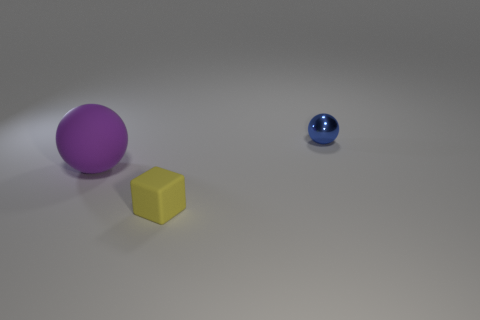Subtract all brown spheres. Subtract all yellow blocks. How many spheres are left? 2 Add 2 big matte spheres. How many objects exist? 5 Subtract all balls. How many objects are left? 1 Add 1 large rubber things. How many large rubber things are left? 2 Add 3 tiny blue balls. How many tiny blue balls exist? 4 Subtract 0 brown spheres. How many objects are left? 3 Subtract all tiny green metallic cubes. Subtract all purple spheres. How many objects are left? 2 